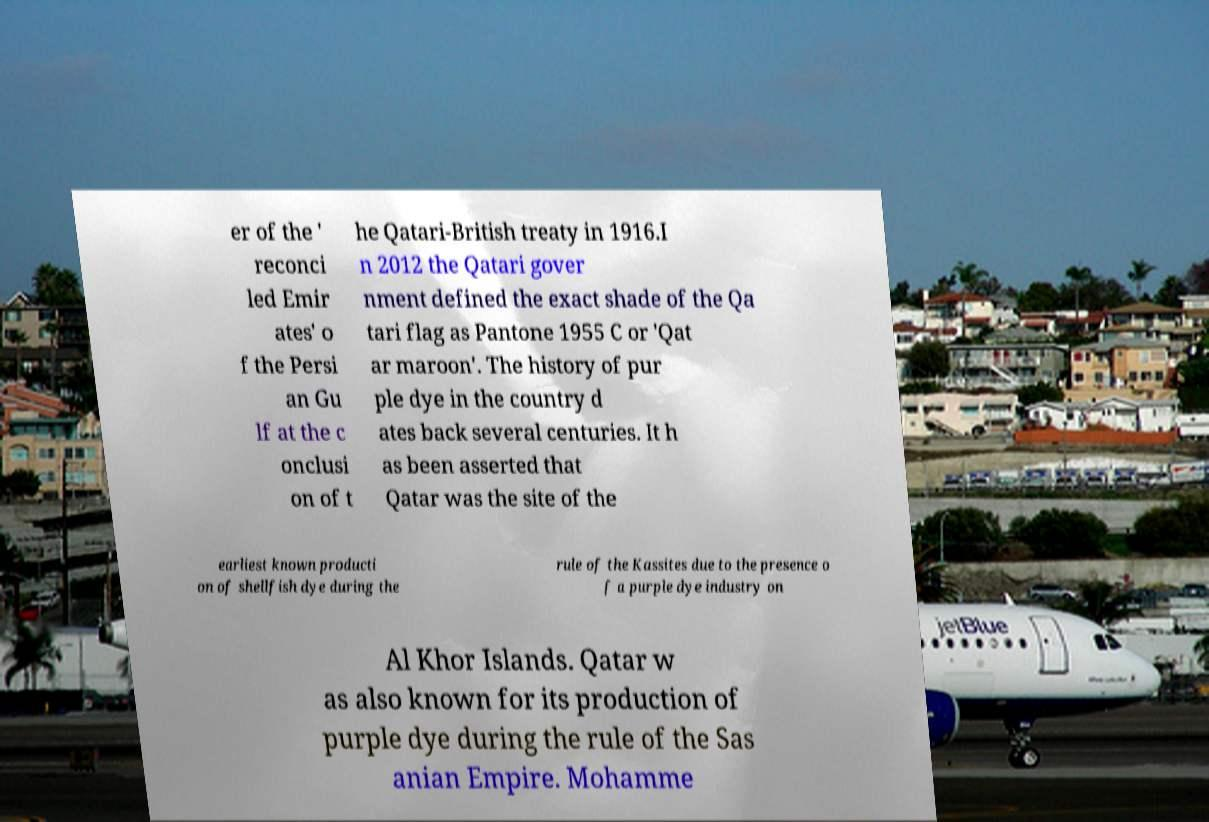Can you read and provide the text displayed in the image?This photo seems to have some interesting text. Can you extract and type it out for me? er of the ' reconci led Emir ates' o f the Persi an Gu lf at the c onclusi on of t he Qatari-British treaty in 1916.I n 2012 the Qatari gover nment defined the exact shade of the Qa tari flag as Pantone 1955 C or 'Qat ar maroon'. The history of pur ple dye in the country d ates back several centuries. It h as been asserted that Qatar was the site of the earliest known producti on of shellfish dye during the rule of the Kassites due to the presence o f a purple dye industry on Al Khor Islands. Qatar w as also known for its production of purple dye during the rule of the Sas anian Empire. Mohamme 